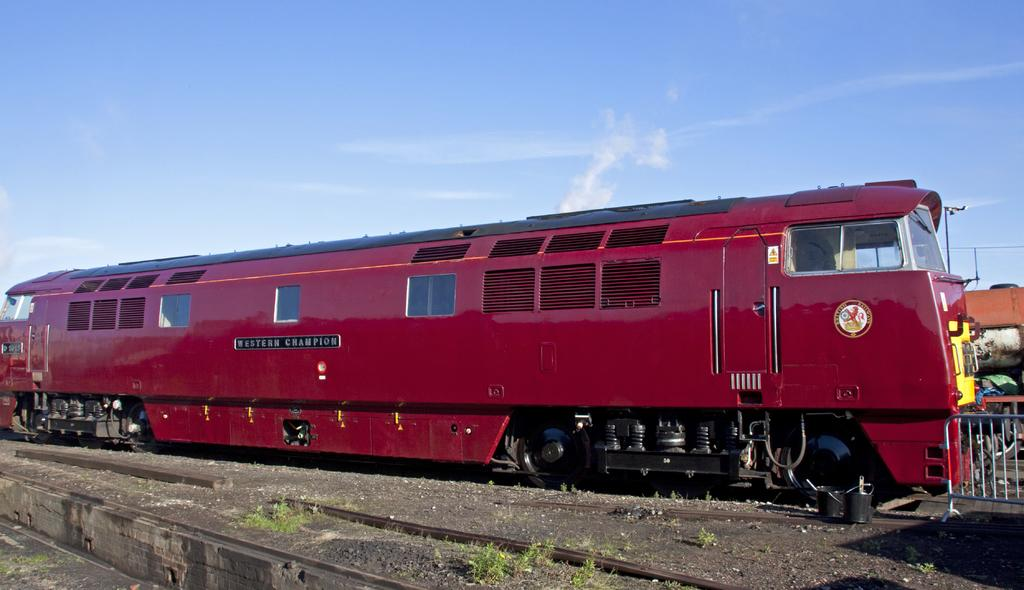What is the main subject of the image? The main subject of the image is a train. Where is the train located in the image? The train is on a railway track. What can be seen on the right side of the image? There is a railing and a shed on the right side of the image. What is visible at the top of the image? The sky is visible at the top of the image. What type of beast can be seen swimming in the ocean in the image? There is no beast or ocean present in the image; it features a train on a railway track with a railing and a shed on the right side. 